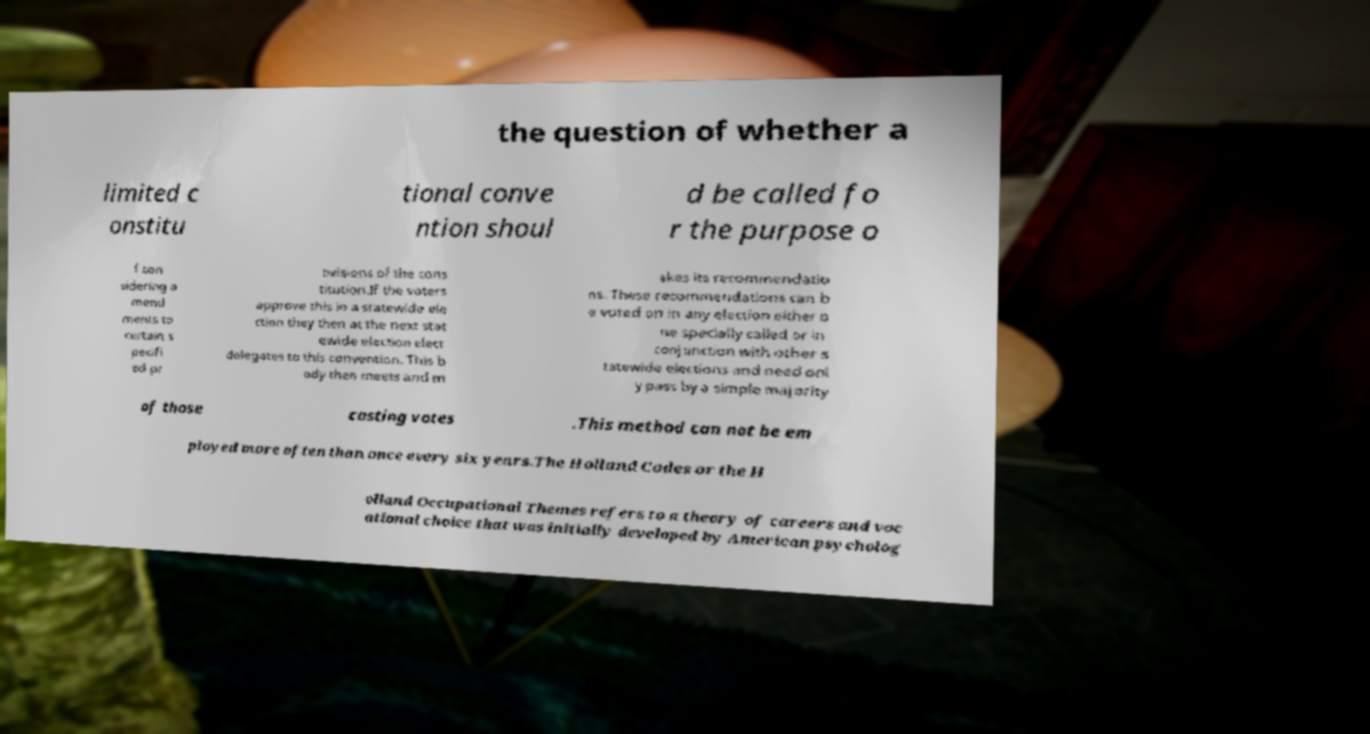Can you read and provide the text displayed in the image?This photo seems to have some interesting text. Can you extract and type it out for me? the question of whether a limited c onstitu tional conve ntion shoul d be called fo r the purpose o f con sidering a mend ments to certain s pecifi ed pr ovisions of the cons titution.If the voters approve this in a statewide ele ction they then at the next stat ewide election elect delegates to this convention. This b ody then meets and m akes its recommendatio ns. These recommendations can b e voted on in any election either o ne specially called or in conjunction with other s tatewide elections and need onl y pass by a simple majority of those casting votes .This method can not be em ployed more often than once every six years.The Holland Codes or the H olland Occupational Themes refers to a theory of careers and voc ational choice that was initially developed by American psycholog 